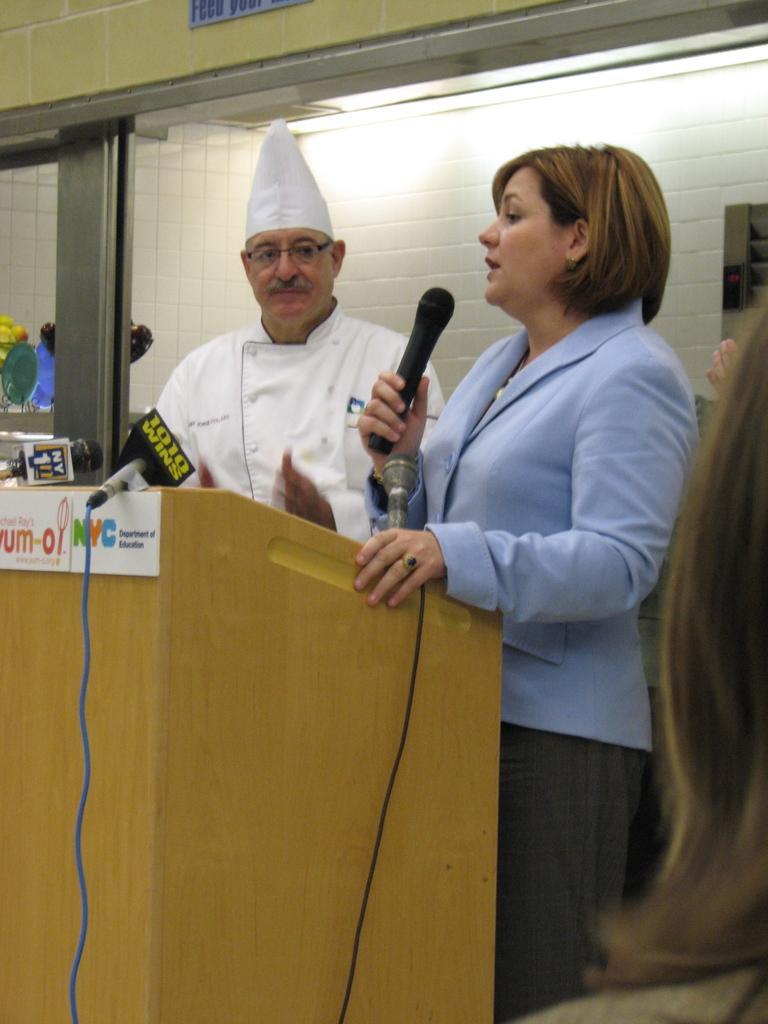Please provide a concise description of this image. This picture shows a man and woman standing at a podium we see a woman speaking with the help of a microphone in her hand 